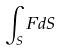<formula> <loc_0><loc_0><loc_500><loc_500>\int _ { S } F d S</formula> 